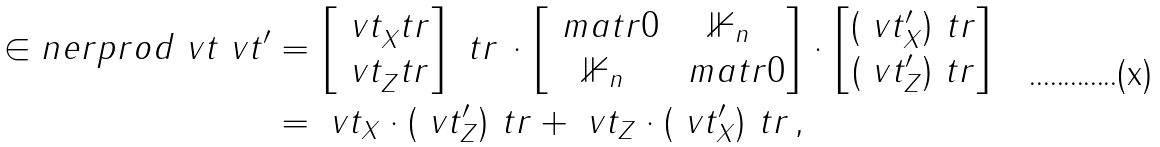<formula> <loc_0><loc_0><loc_500><loc_500>\in n e r p r o d { \ v t } { \ v t ^ { \prime } } & = \begin{bmatrix} \ v t _ { X } ^ { \ } t r \\ \ v t _ { Z } ^ { \ } t r \end{bmatrix} ^ { \ } t r \, \cdot \begin{bmatrix} \ m a t r { 0 } & \mathbb { 1 } _ { n } \\ \mathbb { 1 } _ { n } & \ m a t r { 0 } \end{bmatrix} \cdot \begin{bmatrix} ( \ v t ^ { \prime } _ { X } ) ^ { \ } t r \\ ( \ v t ^ { \prime } _ { Z } ) ^ { \ } t r \end{bmatrix} \\ & = \ v t _ { X } \cdot ( \ v t ^ { \prime } _ { Z } ) ^ { \ } t r + \ v t _ { Z } \cdot ( \ v t ^ { \prime } _ { X } ) ^ { \ } t r \, ,</formula> 